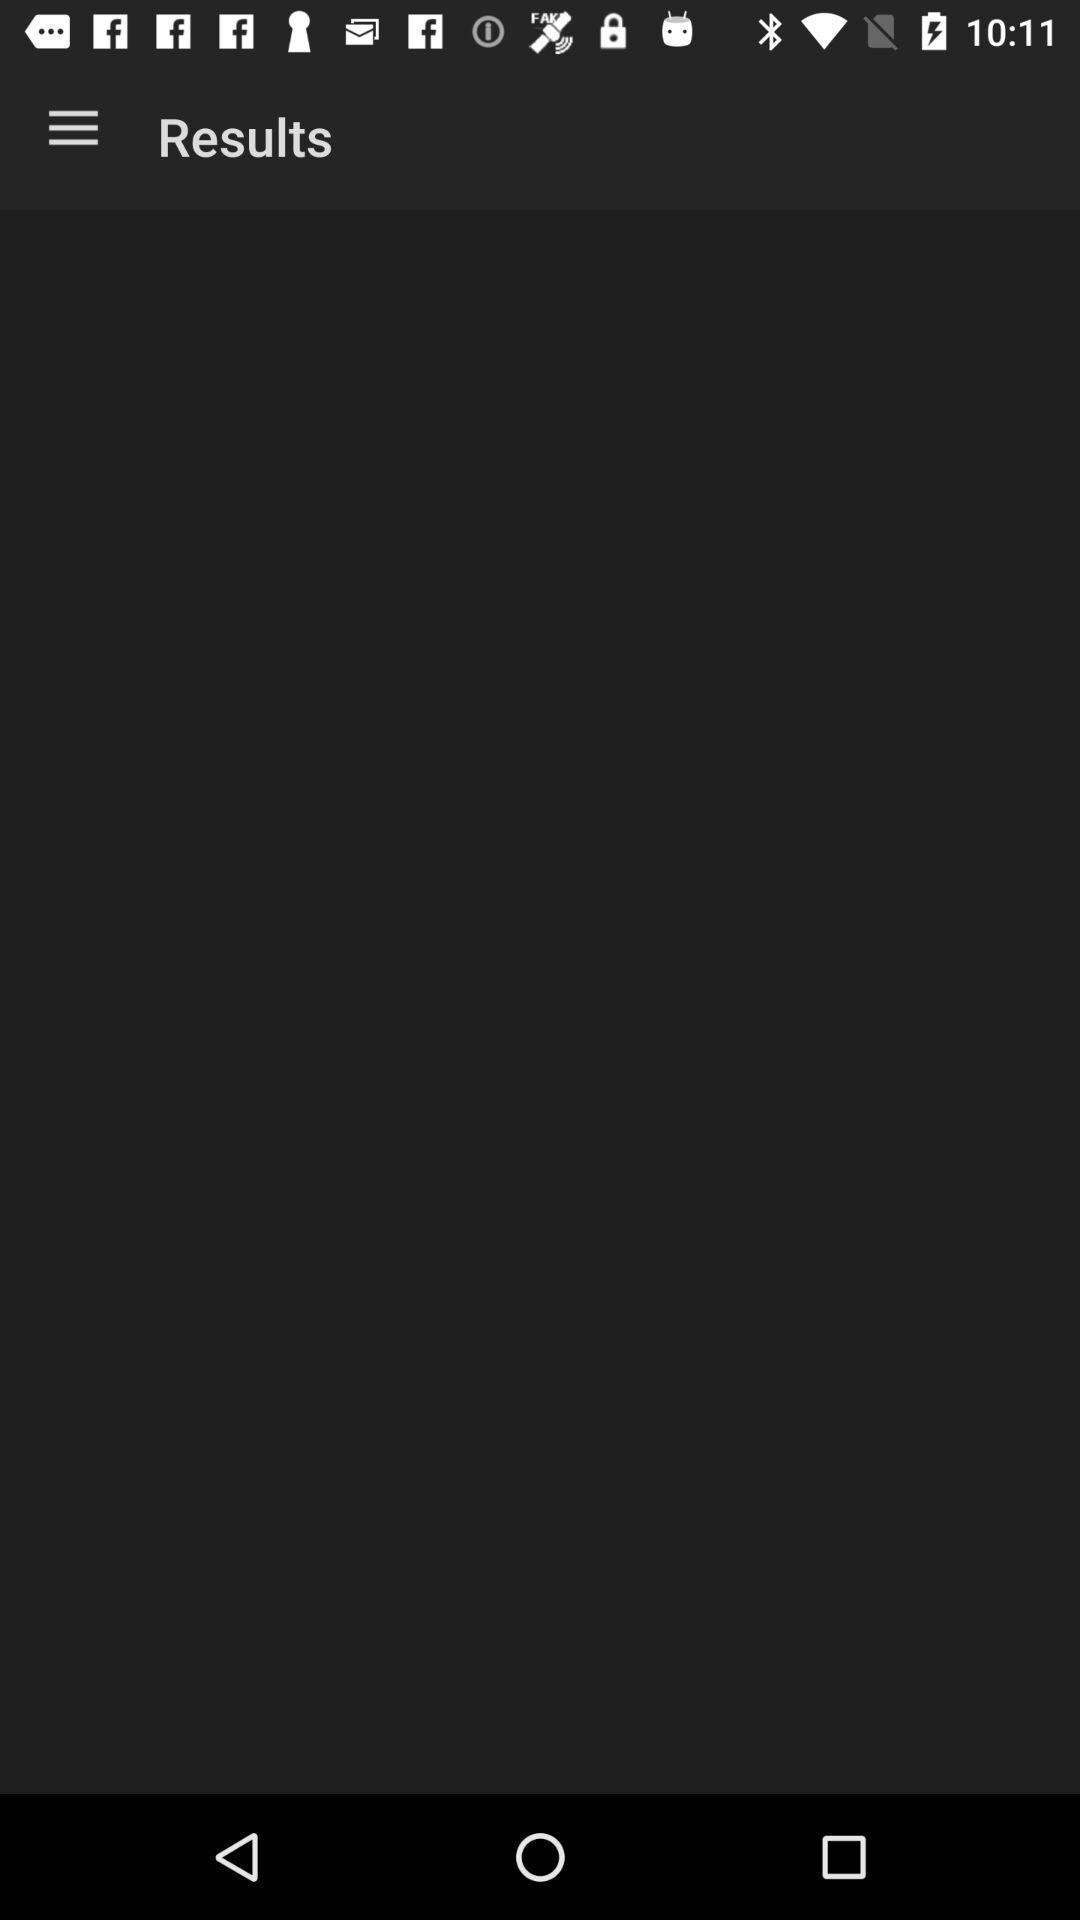Provide a detailed account of this screenshot. Results page. 